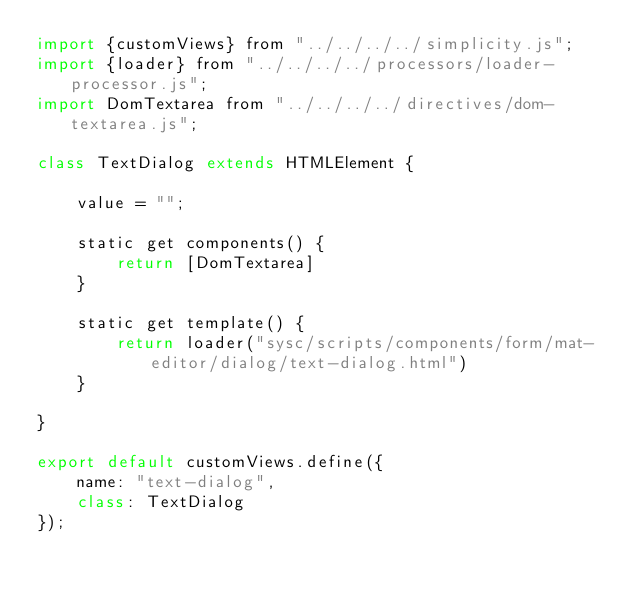Convert code to text. <code><loc_0><loc_0><loc_500><loc_500><_JavaScript_>import {customViews} from "../../../../simplicity.js";
import {loader} from "../../../../processors/loader-processor.js";
import DomTextarea from "../../../../directives/dom-textarea.js";

class TextDialog extends HTMLElement {

    value = "";

    static get components() {
        return [DomTextarea]
    }

    static get template() {
        return loader("sysc/scripts/components/form/mat-editor/dialog/text-dialog.html")
    }

}

export default customViews.define({
    name: "text-dialog",
    class: TextDialog
});</code> 